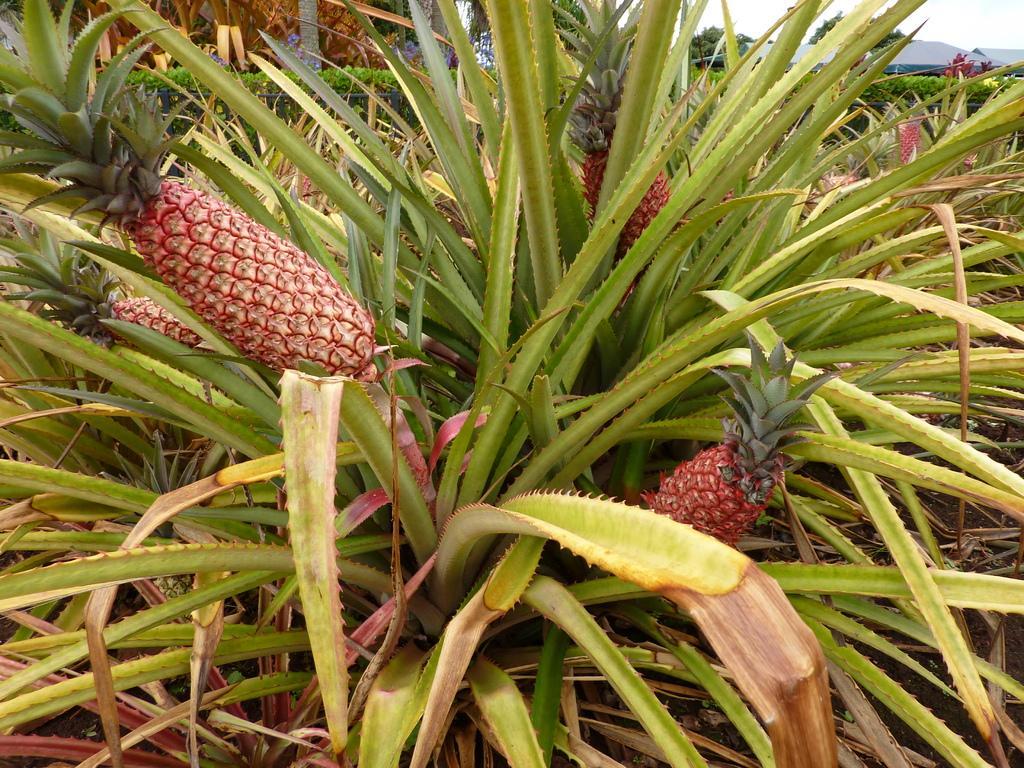Can you describe this image briefly? In the image we can see pineapple plants. Here we can see a mountain and a sky. 